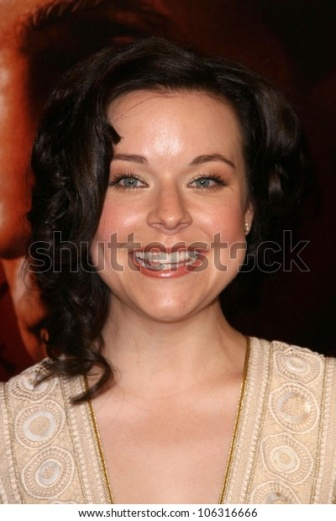What can you infer about the event in the background? From the image, it is inferred that the event in the background is likely a high-profile, glamorous occasion, such as a red carpet event. The red hue and blurred lights suggest an atmosphere filled with excitement and media presence. The event seems to be a gathering of well-dressed individuals, possibly for a movie premiere, award ceremony, or exclusive gala, where attendees showcase fashion and enjoy the spotlight. Create a short story based on this image. Olivia had never felt more radiant. As she stepped onto the red carpet, cameras flashed, and the crowd cheered. Her beige dress, adorned with intricate circular patterns, was a masterpiece she had chosen carefully. The subtle earrings sparkled under the lights, adding just the right amount of elegance to her look. She moved confidently, her smile reflecting the joy and excitement of the evening. Tonight, she was not just an actress attending a premiere but the very embodiment of grace and sophistication. 